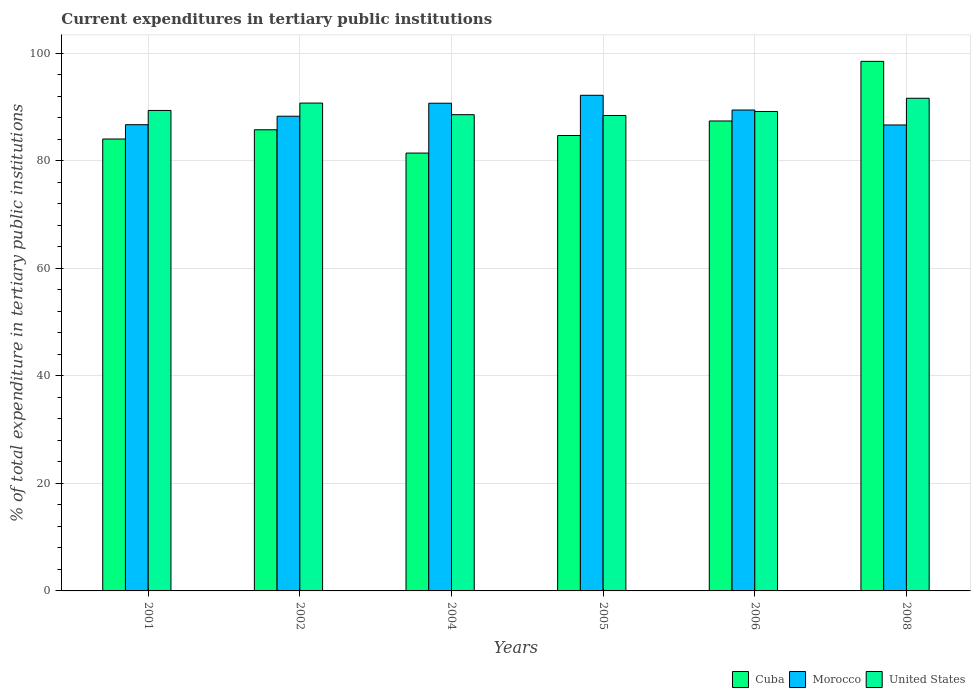How many different coloured bars are there?
Provide a short and direct response. 3. How many groups of bars are there?
Your response must be concise. 6. How many bars are there on the 3rd tick from the right?
Your answer should be very brief. 3. What is the label of the 6th group of bars from the left?
Offer a terse response. 2008. What is the current expenditures in tertiary public institutions in United States in 2004?
Your response must be concise. 88.57. Across all years, what is the maximum current expenditures in tertiary public institutions in Morocco?
Your answer should be compact. 92.18. Across all years, what is the minimum current expenditures in tertiary public institutions in United States?
Offer a very short reply. 88.43. In which year was the current expenditures in tertiary public institutions in United States maximum?
Keep it short and to the point. 2008. In which year was the current expenditures in tertiary public institutions in United States minimum?
Your answer should be compact. 2005. What is the total current expenditures in tertiary public institutions in Cuba in the graph?
Provide a succinct answer. 521.86. What is the difference between the current expenditures in tertiary public institutions in Cuba in 2006 and that in 2008?
Give a very brief answer. -11.09. What is the difference between the current expenditures in tertiary public institutions in Cuba in 2006 and the current expenditures in tertiary public institutions in Morocco in 2004?
Your response must be concise. -3.3. What is the average current expenditures in tertiary public institutions in United States per year?
Ensure brevity in your answer.  89.65. In the year 2002, what is the difference between the current expenditures in tertiary public institutions in Cuba and current expenditures in tertiary public institutions in United States?
Your answer should be very brief. -4.97. What is the ratio of the current expenditures in tertiary public institutions in Morocco in 2002 to that in 2006?
Keep it short and to the point. 0.99. Is the difference between the current expenditures in tertiary public institutions in Cuba in 2004 and 2006 greater than the difference between the current expenditures in tertiary public institutions in United States in 2004 and 2006?
Your answer should be compact. No. What is the difference between the highest and the second highest current expenditures in tertiary public institutions in United States?
Your response must be concise. 0.89. What is the difference between the highest and the lowest current expenditures in tertiary public institutions in Morocco?
Offer a very short reply. 5.52. In how many years, is the current expenditures in tertiary public institutions in United States greater than the average current expenditures in tertiary public institutions in United States taken over all years?
Provide a short and direct response. 2. What does the 3rd bar from the left in 2008 represents?
Provide a short and direct response. United States. What does the 3rd bar from the right in 2002 represents?
Offer a terse response. Cuba. How many bars are there?
Your response must be concise. 18. Are all the bars in the graph horizontal?
Your answer should be compact. No. How many years are there in the graph?
Provide a succinct answer. 6. Are the values on the major ticks of Y-axis written in scientific E-notation?
Offer a very short reply. No. Does the graph contain any zero values?
Make the answer very short. No. Does the graph contain grids?
Give a very brief answer. Yes. Where does the legend appear in the graph?
Your answer should be compact. Bottom right. What is the title of the graph?
Keep it short and to the point. Current expenditures in tertiary public institutions. What is the label or title of the Y-axis?
Make the answer very short. % of total expenditure in tertiary public institutions. What is the % of total expenditure in tertiary public institutions of Cuba in 2001?
Offer a very short reply. 84.05. What is the % of total expenditure in tertiary public institutions in Morocco in 2001?
Make the answer very short. 86.71. What is the % of total expenditure in tertiary public institutions of United States in 2001?
Offer a terse response. 89.36. What is the % of total expenditure in tertiary public institutions of Cuba in 2002?
Your answer should be very brief. 85.77. What is the % of total expenditure in tertiary public institutions in Morocco in 2002?
Your answer should be very brief. 88.29. What is the % of total expenditure in tertiary public institutions in United States in 2002?
Give a very brief answer. 90.74. What is the % of total expenditure in tertiary public institutions in Cuba in 2004?
Your response must be concise. 81.44. What is the % of total expenditure in tertiary public institutions in Morocco in 2004?
Your answer should be compact. 90.71. What is the % of total expenditure in tertiary public institutions of United States in 2004?
Your answer should be very brief. 88.57. What is the % of total expenditure in tertiary public institutions of Cuba in 2005?
Make the answer very short. 84.7. What is the % of total expenditure in tertiary public institutions in Morocco in 2005?
Provide a succinct answer. 92.18. What is the % of total expenditure in tertiary public institutions of United States in 2005?
Provide a succinct answer. 88.43. What is the % of total expenditure in tertiary public institutions in Cuba in 2006?
Keep it short and to the point. 87.41. What is the % of total expenditure in tertiary public institutions of Morocco in 2006?
Offer a terse response. 89.45. What is the % of total expenditure in tertiary public institutions in United States in 2006?
Offer a terse response. 89.17. What is the % of total expenditure in tertiary public institutions in Cuba in 2008?
Your response must be concise. 98.49. What is the % of total expenditure in tertiary public institutions in Morocco in 2008?
Keep it short and to the point. 86.66. What is the % of total expenditure in tertiary public institutions of United States in 2008?
Offer a very short reply. 91.63. Across all years, what is the maximum % of total expenditure in tertiary public institutions of Cuba?
Your answer should be compact. 98.49. Across all years, what is the maximum % of total expenditure in tertiary public institutions in Morocco?
Offer a terse response. 92.18. Across all years, what is the maximum % of total expenditure in tertiary public institutions of United States?
Provide a succinct answer. 91.63. Across all years, what is the minimum % of total expenditure in tertiary public institutions in Cuba?
Give a very brief answer. 81.44. Across all years, what is the minimum % of total expenditure in tertiary public institutions in Morocco?
Your answer should be very brief. 86.66. Across all years, what is the minimum % of total expenditure in tertiary public institutions in United States?
Make the answer very short. 88.43. What is the total % of total expenditure in tertiary public institutions of Cuba in the graph?
Make the answer very short. 521.86. What is the total % of total expenditure in tertiary public institutions in Morocco in the graph?
Offer a terse response. 534. What is the total % of total expenditure in tertiary public institutions of United States in the graph?
Your answer should be very brief. 537.9. What is the difference between the % of total expenditure in tertiary public institutions of Cuba in 2001 and that in 2002?
Offer a very short reply. -1.72. What is the difference between the % of total expenditure in tertiary public institutions of Morocco in 2001 and that in 2002?
Provide a short and direct response. -1.57. What is the difference between the % of total expenditure in tertiary public institutions in United States in 2001 and that in 2002?
Your answer should be very brief. -1.38. What is the difference between the % of total expenditure in tertiary public institutions of Cuba in 2001 and that in 2004?
Keep it short and to the point. 2.61. What is the difference between the % of total expenditure in tertiary public institutions in Morocco in 2001 and that in 2004?
Provide a succinct answer. -4. What is the difference between the % of total expenditure in tertiary public institutions of United States in 2001 and that in 2004?
Provide a succinct answer. 0.79. What is the difference between the % of total expenditure in tertiary public institutions in Cuba in 2001 and that in 2005?
Offer a terse response. -0.65. What is the difference between the % of total expenditure in tertiary public institutions in Morocco in 2001 and that in 2005?
Ensure brevity in your answer.  -5.47. What is the difference between the % of total expenditure in tertiary public institutions of United States in 2001 and that in 2005?
Provide a succinct answer. 0.93. What is the difference between the % of total expenditure in tertiary public institutions of Cuba in 2001 and that in 2006?
Give a very brief answer. -3.36. What is the difference between the % of total expenditure in tertiary public institutions of Morocco in 2001 and that in 2006?
Offer a very short reply. -2.73. What is the difference between the % of total expenditure in tertiary public institutions in United States in 2001 and that in 2006?
Make the answer very short. 0.19. What is the difference between the % of total expenditure in tertiary public institutions in Cuba in 2001 and that in 2008?
Offer a very short reply. -14.44. What is the difference between the % of total expenditure in tertiary public institutions in Morocco in 2001 and that in 2008?
Offer a very short reply. 0.05. What is the difference between the % of total expenditure in tertiary public institutions in United States in 2001 and that in 2008?
Your answer should be compact. -2.27. What is the difference between the % of total expenditure in tertiary public institutions of Cuba in 2002 and that in 2004?
Make the answer very short. 4.33. What is the difference between the % of total expenditure in tertiary public institutions in Morocco in 2002 and that in 2004?
Give a very brief answer. -2.42. What is the difference between the % of total expenditure in tertiary public institutions of United States in 2002 and that in 2004?
Ensure brevity in your answer.  2.16. What is the difference between the % of total expenditure in tertiary public institutions in Cuba in 2002 and that in 2005?
Offer a very short reply. 1.07. What is the difference between the % of total expenditure in tertiary public institutions of Morocco in 2002 and that in 2005?
Give a very brief answer. -3.89. What is the difference between the % of total expenditure in tertiary public institutions in United States in 2002 and that in 2005?
Make the answer very short. 2.31. What is the difference between the % of total expenditure in tertiary public institutions in Cuba in 2002 and that in 2006?
Your answer should be very brief. -1.64. What is the difference between the % of total expenditure in tertiary public institutions of Morocco in 2002 and that in 2006?
Provide a short and direct response. -1.16. What is the difference between the % of total expenditure in tertiary public institutions of United States in 2002 and that in 2006?
Offer a very short reply. 1.56. What is the difference between the % of total expenditure in tertiary public institutions in Cuba in 2002 and that in 2008?
Give a very brief answer. -12.72. What is the difference between the % of total expenditure in tertiary public institutions of Morocco in 2002 and that in 2008?
Your answer should be very brief. 1.63. What is the difference between the % of total expenditure in tertiary public institutions of United States in 2002 and that in 2008?
Your answer should be very brief. -0.89. What is the difference between the % of total expenditure in tertiary public institutions in Cuba in 2004 and that in 2005?
Offer a terse response. -3.27. What is the difference between the % of total expenditure in tertiary public institutions of Morocco in 2004 and that in 2005?
Your answer should be very brief. -1.47. What is the difference between the % of total expenditure in tertiary public institutions of United States in 2004 and that in 2005?
Provide a succinct answer. 0.15. What is the difference between the % of total expenditure in tertiary public institutions of Cuba in 2004 and that in 2006?
Provide a short and direct response. -5.97. What is the difference between the % of total expenditure in tertiary public institutions in Morocco in 2004 and that in 2006?
Provide a succinct answer. 1.26. What is the difference between the % of total expenditure in tertiary public institutions of United States in 2004 and that in 2006?
Your answer should be compact. -0.6. What is the difference between the % of total expenditure in tertiary public institutions in Cuba in 2004 and that in 2008?
Your response must be concise. -17.06. What is the difference between the % of total expenditure in tertiary public institutions of Morocco in 2004 and that in 2008?
Your answer should be compact. 4.05. What is the difference between the % of total expenditure in tertiary public institutions of United States in 2004 and that in 2008?
Your answer should be very brief. -3.06. What is the difference between the % of total expenditure in tertiary public institutions of Cuba in 2005 and that in 2006?
Ensure brevity in your answer.  -2.7. What is the difference between the % of total expenditure in tertiary public institutions of Morocco in 2005 and that in 2006?
Your response must be concise. 2.74. What is the difference between the % of total expenditure in tertiary public institutions of United States in 2005 and that in 2006?
Your answer should be compact. -0.75. What is the difference between the % of total expenditure in tertiary public institutions of Cuba in 2005 and that in 2008?
Your answer should be compact. -13.79. What is the difference between the % of total expenditure in tertiary public institutions in Morocco in 2005 and that in 2008?
Give a very brief answer. 5.52. What is the difference between the % of total expenditure in tertiary public institutions in United States in 2005 and that in 2008?
Make the answer very short. -3.2. What is the difference between the % of total expenditure in tertiary public institutions of Cuba in 2006 and that in 2008?
Your response must be concise. -11.09. What is the difference between the % of total expenditure in tertiary public institutions of Morocco in 2006 and that in 2008?
Provide a succinct answer. 2.78. What is the difference between the % of total expenditure in tertiary public institutions in United States in 2006 and that in 2008?
Your answer should be very brief. -2.46. What is the difference between the % of total expenditure in tertiary public institutions of Cuba in 2001 and the % of total expenditure in tertiary public institutions of Morocco in 2002?
Keep it short and to the point. -4.24. What is the difference between the % of total expenditure in tertiary public institutions of Cuba in 2001 and the % of total expenditure in tertiary public institutions of United States in 2002?
Offer a terse response. -6.69. What is the difference between the % of total expenditure in tertiary public institutions in Morocco in 2001 and the % of total expenditure in tertiary public institutions in United States in 2002?
Ensure brevity in your answer.  -4.02. What is the difference between the % of total expenditure in tertiary public institutions in Cuba in 2001 and the % of total expenditure in tertiary public institutions in Morocco in 2004?
Offer a terse response. -6.66. What is the difference between the % of total expenditure in tertiary public institutions in Cuba in 2001 and the % of total expenditure in tertiary public institutions in United States in 2004?
Make the answer very short. -4.52. What is the difference between the % of total expenditure in tertiary public institutions in Morocco in 2001 and the % of total expenditure in tertiary public institutions in United States in 2004?
Offer a terse response. -1.86. What is the difference between the % of total expenditure in tertiary public institutions in Cuba in 2001 and the % of total expenditure in tertiary public institutions in Morocco in 2005?
Ensure brevity in your answer.  -8.13. What is the difference between the % of total expenditure in tertiary public institutions in Cuba in 2001 and the % of total expenditure in tertiary public institutions in United States in 2005?
Keep it short and to the point. -4.38. What is the difference between the % of total expenditure in tertiary public institutions in Morocco in 2001 and the % of total expenditure in tertiary public institutions in United States in 2005?
Provide a short and direct response. -1.71. What is the difference between the % of total expenditure in tertiary public institutions of Cuba in 2001 and the % of total expenditure in tertiary public institutions of Morocco in 2006?
Your answer should be very brief. -5.39. What is the difference between the % of total expenditure in tertiary public institutions of Cuba in 2001 and the % of total expenditure in tertiary public institutions of United States in 2006?
Your answer should be compact. -5.12. What is the difference between the % of total expenditure in tertiary public institutions in Morocco in 2001 and the % of total expenditure in tertiary public institutions in United States in 2006?
Your response must be concise. -2.46. What is the difference between the % of total expenditure in tertiary public institutions of Cuba in 2001 and the % of total expenditure in tertiary public institutions of Morocco in 2008?
Provide a short and direct response. -2.61. What is the difference between the % of total expenditure in tertiary public institutions of Cuba in 2001 and the % of total expenditure in tertiary public institutions of United States in 2008?
Offer a very short reply. -7.58. What is the difference between the % of total expenditure in tertiary public institutions in Morocco in 2001 and the % of total expenditure in tertiary public institutions in United States in 2008?
Provide a short and direct response. -4.92. What is the difference between the % of total expenditure in tertiary public institutions of Cuba in 2002 and the % of total expenditure in tertiary public institutions of Morocco in 2004?
Give a very brief answer. -4.94. What is the difference between the % of total expenditure in tertiary public institutions in Cuba in 2002 and the % of total expenditure in tertiary public institutions in United States in 2004?
Your answer should be very brief. -2.81. What is the difference between the % of total expenditure in tertiary public institutions in Morocco in 2002 and the % of total expenditure in tertiary public institutions in United States in 2004?
Keep it short and to the point. -0.29. What is the difference between the % of total expenditure in tertiary public institutions in Cuba in 2002 and the % of total expenditure in tertiary public institutions in Morocco in 2005?
Provide a succinct answer. -6.41. What is the difference between the % of total expenditure in tertiary public institutions in Cuba in 2002 and the % of total expenditure in tertiary public institutions in United States in 2005?
Your answer should be compact. -2.66. What is the difference between the % of total expenditure in tertiary public institutions of Morocco in 2002 and the % of total expenditure in tertiary public institutions of United States in 2005?
Provide a short and direct response. -0.14. What is the difference between the % of total expenditure in tertiary public institutions in Cuba in 2002 and the % of total expenditure in tertiary public institutions in Morocco in 2006?
Ensure brevity in your answer.  -3.68. What is the difference between the % of total expenditure in tertiary public institutions of Cuba in 2002 and the % of total expenditure in tertiary public institutions of United States in 2006?
Ensure brevity in your answer.  -3.4. What is the difference between the % of total expenditure in tertiary public institutions of Morocco in 2002 and the % of total expenditure in tertiary public institutions of United States in 2006?
Offer a terse response. -0.88. What is the difference between the % of total expenditure in tertiary public institutions of Cuba in 2002 and the % of total expenditure in tertiary public institutions of Morocco in 2008?
Provide a succinct answer. -0.89. What is the difference between the % of total expenditure in tertiary public institutions in Cuba in 2002 and the % of total expenditure in tertiary public institutions in United States in 2008?
Provide a succinct answer. -5.86. What is the difference between the % of total expenditure in tertiary public institutions in Morocco in 2002 and the % of total expenditure in tertiary public institutions in United States in 2008?
Ensure brevity in your answer.  -3.34. What is the difference between the % of total expenditure in tertiary public institutions in Cuba in 2004 and the % of total expenditure in tertiary public institutions in Morocco in 2005?
Provide a succinct answer. -10.75. What is the difference between the % of total expenditure in tertiary public institutions in Cuba in 2004 and the % of total expenditure in tertiary public institutions in United States in 2005?
Offer a terse response. -6.99. What is the difference between the % of total expenditure in tertiary public institutions in Morocco in 2004 and the % of total expenditure in tertiary public institutions in United States in 2005?
Your answer should be very brief. 2.28. What is the difference between the % of total expenditure in tertiary public institutions in Cuba in 2004 and the % of total expenditure in tertiary public institutions in Morocco in 2006?
Your answer should be very brief. -8.01. What is the difference between the % of total expenditure in tertiary public institutions in Cuba in 2004 and the % of total expenditure in tertiary public institutions in United States in 2006?
Make the answer very short. -7.74. What is the difference between the % of total expenditure in tertiary public institutions in Morocco in 2004 and the % of total expenditure in tertiary public institutions in United States in 2006?
Provide a short and direct response. 1.54. What is the difference between the % of total expenditure in tertiary public institutions of Cuba in 2004 and the % of total expenditure in tertiary public institutions of Morocco in 2008?
Provide a succinct answer. -5.23. What is the difference between the % of total expenditure in tertiary public institutions in Cuba in 2004 and the % of total expenditure in tertiary public institutions in United States in 2008?
Provide a short and direct response. -10.2. What is the difference between the % of total expenditure in tertiary public institutions of Morocco in 2004 and the % of total expenditure in tertiary public institutions of United States in 2008?
Provide a short and direct response. -0.92. What is the difference between the % of total expenditure in tertiary public institutions in Cuba in 2005 and the % of total expenditure in tertiary public institutions in Morocco in 2006?
Provide a short and direct response. -4.74. What is the difference between the % of total expenditure in tertiary public institutions in Cuba in 2005 and the % of total expenditure in tertiary public institutions in United States in 2006?
Your response must be concise. -4.47. What is the difference between the % of total expenditure in tertiary public institutions of Morocco in 2005 and the % of total expenditure in tertiary public institutions of United States in 2006?
Offer a very short reply. 3.01. What is the difference between the % of total expenditure in tertiary public institutions of Cuba in 2005 and the % of total expenditure in tertiary public institutions of Morocco in 2008?
Offer a very short reply. -1.96. What is the difference between the % of total expenditure in tertiary public institutions of Cuba in 2005 and the % of total expenditure in tertiary public institutions of United States in 2008?
Ensure brevity in your answer.  -6.93. What is the difference between the % of total expenditure in tertiary public institutions in Morocco in 2005 and the % of total expenditure in tertiary public institutions in United States in 2008?
Make the answer very short. 0.55. What is the difference between the % of total expenditure in tertiary public institutions of Cuba in 2006 and the % of total expenditure in tertiary public institutions of Morocco in 2008?
Give a very brief answer. 0.74. What is the difference between the % of total expenditure in tertiary public institutions in Cuba in 2006 and the % of total expenditure in tertiary public institutions in United States in 2008?
Provide a succinct answer. -4.23. What is the difference between the % of total expenditure in tertiary public institutions of Morocco in 2006 and the % of total expenditure in tertiary public institutions of United States in 2008?
Offer a terse response. -2.19. What is the average % of total expenditure in tertiary public institutions in Cuba per year?
Provide a succinct answer. 86.98. What is the average % of total expenditure in tertiary public institutions of Morocco per year?
Your response must be concise. 89. What is the average % of total expenditure in tertiary public institutions in United States per year?
Provide a short and direct response. 89.65. In the year 2001, what is the difference between the % of total expenditure in tertiary public institutions in Cuba and % of total expenditure in tertiary public institutions in Morocco?
Provide a succinct answer. -2.66. In the year 2001, what is the difference between the % of total expenditure in tertiary public institutions of Cuba and % of total expenditure in tertiary public institutions of United States?
Your answer should be compact. -5.31. In the year 2001, what is the difference between the % of total expenditure in tertiary public institutions in Morocco and % of total expenditure in tertiary public institutions in United States?
Ensure brevity in your answer.  -2.65. In the year 2002, what is the difference between the % of total expenditure in tertiary public institutions of Cuba and % of total expenditure in tertiary public institutions of Morocco?
Provide a succinct answer. -2.52. In the year 2002, what is the difference between the % of total expenditure in tertiary public institutions in Cuba and % of total expenditure in tertiary public institutions in United States?
Ensure brevity in your answer.  -4.97. In the year 2002, what is the difference between the % of total expenditure in tertiary public institutions in Morocco and % of total expenditure in tertiary public institutions in United States?
Ensure brevity in your answer.  -2.45. In the year 2004, what is the difference between the % of total expenditure in tertiary public institutions of Cuba and % of total expenditure in tertiary public institutions of Morocco?
Your answer should be compact. -9.27. In the year 2004, what is the difference between the % of total expenditure in tertiary public institutions in Cuba and % of total expenditure in tertiary public institutions in United States?
Your answer should be very brief. -7.14. In the year 2004, what is the difference between the % of total expenditure in tertiary public institutions in Morocco and % of total expenditure in tertiary public institutions in United States?
Provide a succinct answer. 2.13. In the year 2005, what is the difference between the % of total expenditure in tertiary public institutions of Cuba and % of total expenditure in tertiary public institutions of Morocco?
Offer a very short reply. -7.48. In the year 2005, what is the difference between the % of total expenditure in tertiary public institutions of Cuba and % of total expenditure in tertiary public institutions of United States?
Keep it short and to the point. -3.72. In the year 2005, what is the difference between the % of total expenditure in tertiary public institutions of Morocco and % of total expenditure in tertiary public institutions of United States?
Make the answer very short. 3.76. In the year 2006, what is the difference between the % of total expenditure in tertiary public institutions in Cuba and % of total expenditure in tertiary public institutions in Morocco?
Make the answer very short. -2.04. In the year 2006, what is the difference between the % of total expenditure in tertiary public institutions in Cuba and % of total expenditure in tertiary public institutions in United States?
Offer a very short reply. -1.77. In the year 2006, what is the difference between the % of total expenditure in tertiary public institutions in Morocco and % of total expenditure in tertiary public institutions in United States?
Offer a terse response. 0.27. In the year 2008, what is the difference between the % of total expenditure in tertiary public institutions in Cuba and % of total expenditure in tertiary public institutions in Morocco?
Your answer should be compact. 11.83. In the year 2008, what is the difference between the % of total expenditure in tertiary public institutions in Cuba and % of total expenditure in tertiary public institutions in United States?
Make the answer very short. 6.86. In the year 2008, what is the difference between the % of total expenditure in tertiary public institutions in Morocco and % of total expenditure in tertiary public institutions in United States?
Make the answer very short. -4.97. What is the ratio of the % of total expenditure in tertiary public institutions of Cuba in 2001 to that in 2002?
Make the answer very short. 0.98. What is the ratio of the % of total expenditure in tertiary public institutions in Morocco in 2001 to that in 2002?
Your answer should be compact. 0.98. What is the ratio of the % of total expenditure in tertiary public institutions of United States in 2001 to that in 2002?
Give a very brief answer. 0.98. What is the ratio of the % of total expenditure in tertiary public institutions of Cuba in 2001 to that in 2004?
Offer a terse response. 1.03. What is the ratio of the % of total expenditure in tertiary public institutions in Morocco in 2001 to that in 2004?
Ensure brevity in your answer.  0.96. What is the ratio of the % of total expenditure in tertiary public institutions in United States in 2001 to that in 2004?
Provide a short and direct response. 1.01. What is the ratio of the % of total expenditure in tertiary public institutions in Cuba in 2001 to that in 2005?
Make the answer very short. 0.99. What is the ratio of the % of total expenditure in tertiary public institutions of Morocco in 2001 to that in 2005?
Make the answer very short. 0.94. What is the ratio of the % of total expenditure in tertiary public institutions of United States in 2001 to that in 2005?
Your answer should be compact. 1.01. What is the ratio of the % of total expenditure in tertiary public institutions of Cuba in 2001 to that in 2006?
Provide a short and direct response. 0.96. What is the ratio of the % of total expenditure in tertiary public institutions of Morocco in 2001 to that in 2006?
Offer a very short reply. 0.97. What is the ratio of the % of total expenditure in tertiary public institutions of United States in 2001 to that in 2006?
Your answer should be compact. 1. What is the ratio of the % of total expenditure in tertiary public institutions of Cuba in 2001 to that in 2008?
Ensure brevity in your answer.  0.85. What is the ratio of the % of total expenditure in tertiary public institutions of Morocco in 2001 to that in 2008?
Keep it short and to the point. 1. What is the ratio of the % of total expenditure in tertiary public institutions of United States in 2001 to that in 2008?
Ensure brevity in your answer.  0.98. What is the ratio of the % of total expenditure in tertiary public institutions of Cuba in 2002 to that in 2004?
Ensure brevity in your answer.  1.05. What is the ratio of the % of total expenditure in tertiary public institutions of Morocco in 2002 to that in 2004?
Offer a terse response. 0.97. What is the ratio of the % of total expenditure in tertiary public institutions of United States in 2002 to that in 2004?
Ensure brevity in your answer.  1.02. What is the ratio of the % of total expenditure in tertiary public institutions in Cuba in 2002 to that in 2005?
Your answer should be compact. 1.01. What is the ratio of the % of total expenditure in tertiary public institutions in Morocco in 2002 to that in 2005?
Provide a short and direct response. 0.96. What is the ratio of the % of total expenditure in tertiary public institutions in United States in 2002 to that in 2005?
Your answer should be compact. 1.03. What is the ratio of the % of total expenditure in tertiary public institutions of Cuba in 2002 to that in 2006?
Provide a short and direct response. 0.98. What is the ratio of the % of total expenditure in tertiary public institutions of Morocco in 2002 to that in 2006?
Provide a succinct answer. 0.99. What is the ratio of the % of total expenditure in tertiary public institutions in United States in 2002 to that in 2006?
Your response must be concise. 1.02. What is the ratio of the % of total expenditure in tertiary public institutions in Cuba in 2002 to that in 2008?
Keep it short and to the point. 0.87. What is the ratio of the % of total expenditure in tertiary public institutions of Morocco in 2002 to that in 2008?
Provide a short and direct response. 1.02. What is the ratio of the % of total expenditure in tertiary public institutions in United States in 2002 to that in 2008?
Your response must be concise. 0.99. What is the ratio of the % of total expenditure in tertiary public institutions in Cuba in 2004 to that in 2005?
Provide a succinct answer. 0.96. What is the ratio of the % of total expenditure in tertiary public institutions in United States in 2004 to that in 2005?
Your answer should be compact. 1. What is the ratio of the % of total expenditure in tertiary public institutions of Cuba in 2004 to that in 2006?
Your answer should be compact. 0.93. What is the ratio of the % of total expenditure in tertiary public institutions in Morocco in 2004 to that in 2006?
Your response must be concise. 1.01. What is the ratio of the % of total expenditure in tertiary public institutions of Cuba in 2004 to that in 2008?
Give a very brief answer. 0.83. What is the ratio of the % of total expenditure in tertiary public institutions in Morocco in 2004 to that in 2008?
Your response must be concise. 1.05. What is the ratio of the % of total expenditure in tertiary public institutions of United States in 2004 to that in 2008?
Provide a succinct answer. 0.97. What is the ratio of the % of total expenditure in tertiary public institutions in Cuba in 2005 to that in 2006?
Offer a terse response. 0.97. What is the ratio of the % of total expenditure in tertiary public institutions of Morocco in 2005 to that in 2006?
Ensure brevity in your answer.  1.03. What is the ratio of the % of total expenditure in tertiary public institutions in United States in 2005 to that in 2006?
Give a very brief answer. 0.99. What is the ratio of the % of total expenditure in tertiary public institutions in Cuba in 2005 to that in 2008?
Provide a succinct answer. 0.86. What is the ratio of the % of total expenditure in tertiary public institutions of Morocco in 2005 to that in 2008?
Your answer should be very brief. 1.06. What is the ratio of the % of total expenditure in tertiary public institutions of United States in 2005 to that in 2008?
Provide a short and direct response. 0.96. What is the ratio of the % of total expenditure in tertiary public institutions of Cuba in 2006 to that in 2008?
Ensure brevity in your answer.  0.89. What is the ratio of the % of total expenditure in tertiary public institutions in Morocco in 2006 to that in 2008?
Offer a very short reply. 1.03. What is the ratio of the % of total expenditure in tertiary public institutions of United States in 2006 to that in 2008?
Ensure brevity in your answer.  0.97. What is the difference between the highest and the second highest % of total expenditure in tertiary public institutions of Cuba?
Give a very brief answer. 11.09. What is the difference between the highest and the second highest % of total expenditure in tertiary public institutions in Morocco?
Provide a short and direct response. 1.47. What is the difference between the highest and the second highest % of total expenditure in tertiary public institutions in United States?
Keep it short and to the point. 0.89. What is the difference between the highest and the lowest % of total expenditure in tertiary public institutions in Cuba?
Provide a short and direct response. 17.06. What is the difference between the highest and the lowest % of total expenditure in tertiary public institutions in Morocco?
Offer a terse response. 5.52. What is the difference between the highest and the lowest % of total expenditure in tertiary public institutions of United States?
Provide a short and direct response. 3.2. 